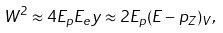<formula> <loc_0><loc_0><loc_500><loc_500>W ^ { 2 } \approx 4 E _ { p } E _ { e } y \approx 2 E _ { p } ( E - p _ { Z } ) _ { V } ,</formula> 